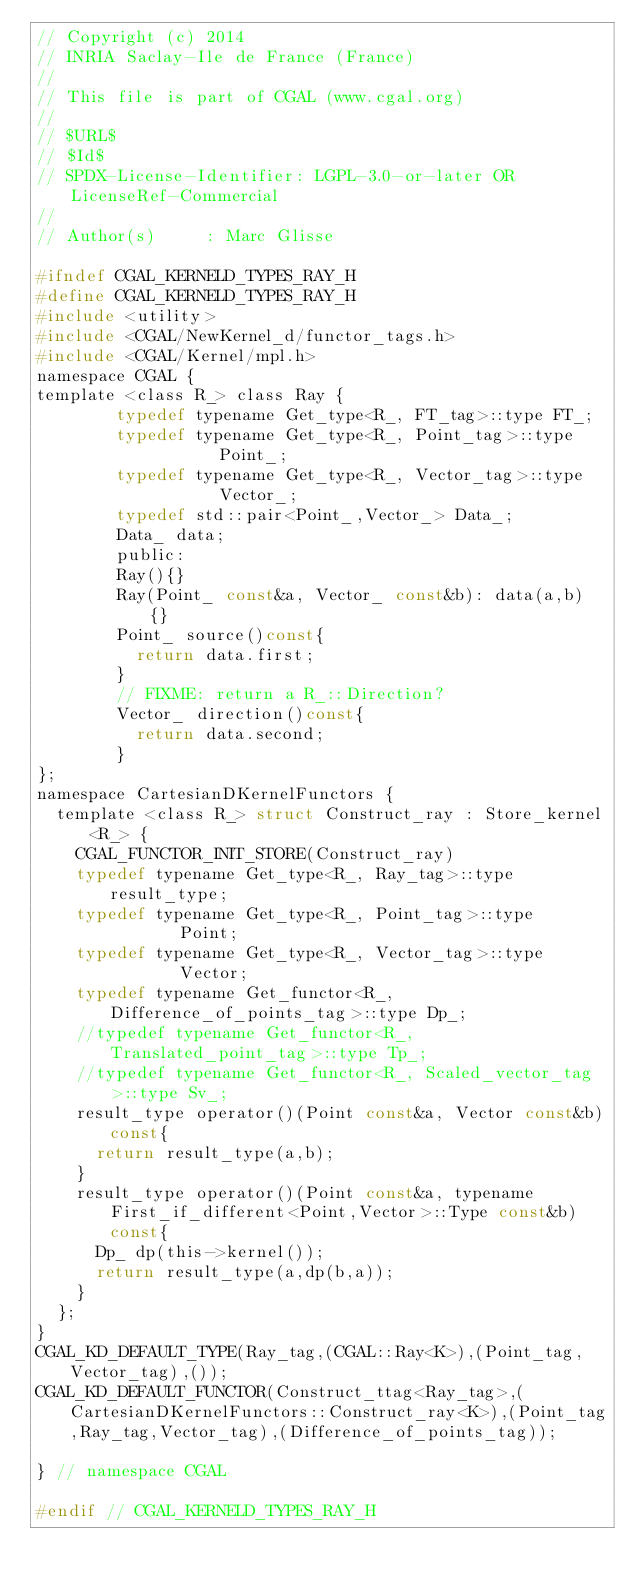<code> <loc_0><loc_0><loc_500><loc_500><_C_>// Copyright (c) 2014
// INRIA Saclay-Ile de France (France)
//
// This file is part of CGAL (www.cgal.org)
//
// $URL$
// $Id$
// SPDX-License-Identifier: LGPL-3.0-or-later OR LicenseRef-Commercial
//
// Author(s)     : Marc Glisse

#ifndef CGAL_KERNELD_TYPES_RAY_H
#define CGAL_KERNELD_TYPES_RAY_H
#include <utility>
#include <CGAL/NewKernel_d/functor_tags.h>
#include <CGAL/Kernel/mpl.h>
namespace CGAL {
template <class R_> class Ray {
        typedef typename Get_type<R_, FT_tag>::type FT_;
        typedef typename Get_type<R_, Point_tag>::type        Point_;
        typedef typename Get_type<R_, Vector_tag>::type        Vector_;
        typedef std::pair<Point_,Vector_> Data_;
        Data_ data;
        public:
        Ray(){}
        Ray(Point_ const&a, Vector_ const&b): data(a,b) {}
        Point_ source()const{
          return data.first;
        }
        // FIXME: return a R_::Direction?
        Vector_ direction()const{
          return data.second;
        }
};
namespace CartesianDKernelFunctors {
  template <class R_> struct Construct_ray : Store_kernel<R_> {
    CGAL_FUNCTOR_INIT_STORE(Construct_ray)
    typedef typename Get_type<R_, Ray_tag>::type        result_type;
    typedef typename Get_type<R_, Point_tag>::type        Point;
    typedef typename Get_type<R_, Vector_tag>::type        Vector;
    typedef typename Get_functor<R_, Difference_of_points_tag>::type Dp_;
    //typedef typename Get_functor<R_, Translated_point_tag>::type Tp_;
    //typedef typename Get_functor<R_, Scaled_vector_tag>::type Sv_;
    result_type operator()(Point const&a, Vector const&b)const{
      return result_type(a,b);
    }
    result_type operator()(Point const&a, typename First_if_different<Point,Vector>::Type const&b)const{
      Dp_ dp(this->kernel());
      return result_type(a,dp(b,a));
    }
  };
}
CGAL_KD_DEFAULT_TYPE(Ray_tag,(CGAL::Ray<K>),(Point_tag,Vector_tag),());
CGAL_KD_DEFAULT_FUNCTOR(Construct_ttag<Ray_tag>,(CartesianDKernelFunctors::Construct_ray<K>),(Point_tag,Ray_tag,Vector_tag),(Difference_of_points_tag));

} // namespace CGAL

#endif // CGAL_KERNELD_TYPES_RAY_H
</code> 